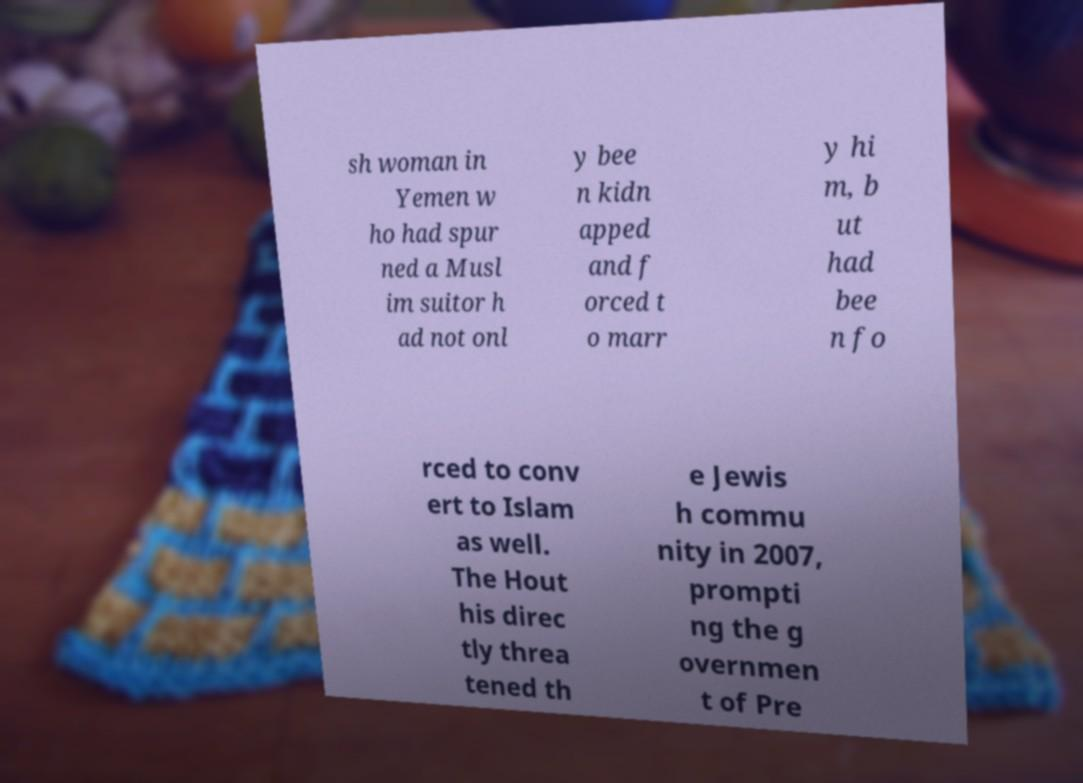Can you read and provide the text displayed in the image?This photo seems to have some interesting text. Can you extract and type it out for me? sh woman in Yemen w ho had spur ned a Musl im suitor h ad not onl y bee n kidn apped and f orced t o marr y hi m, b ut had bee n fo rced to conv ert to Islam as well. The Hout his direc tly threa tened th e Jewis h commu nity in 2007, prompti ng the g overnmen t of Pre 